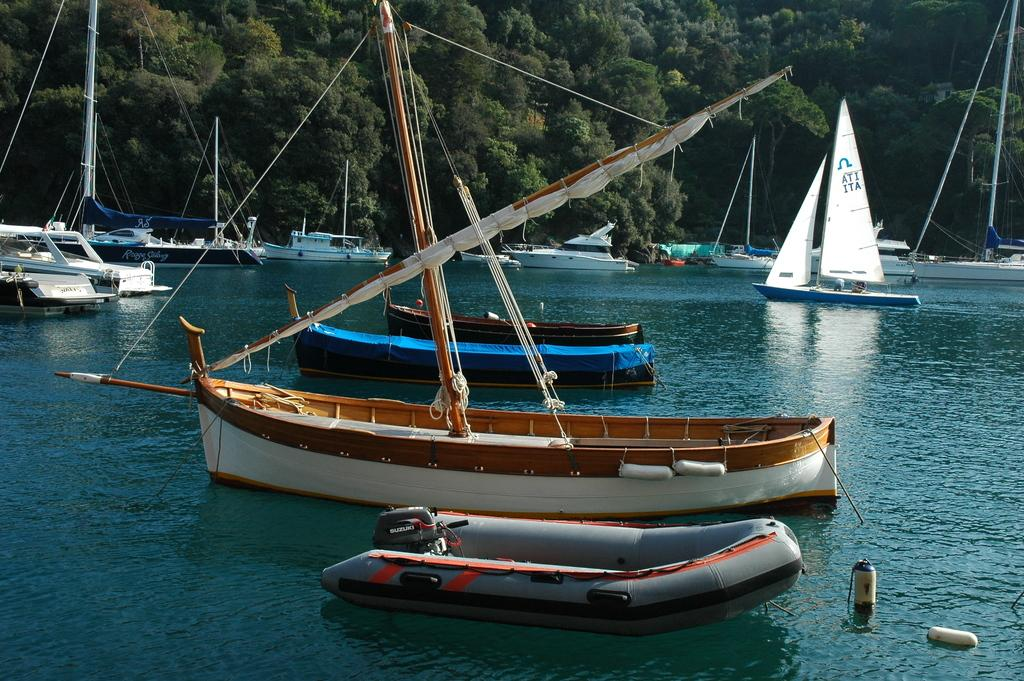What is the primary element in the image? There is water in the image. What is present on the water? There are boats on the water. What can be seen in the background of the image? There are green color trees in the background of the image. What is the condition of the bird in the image? There is no bird present in the image. Who is the owner of the trees in the image? The image does not provide information about the ownership of the trees. 